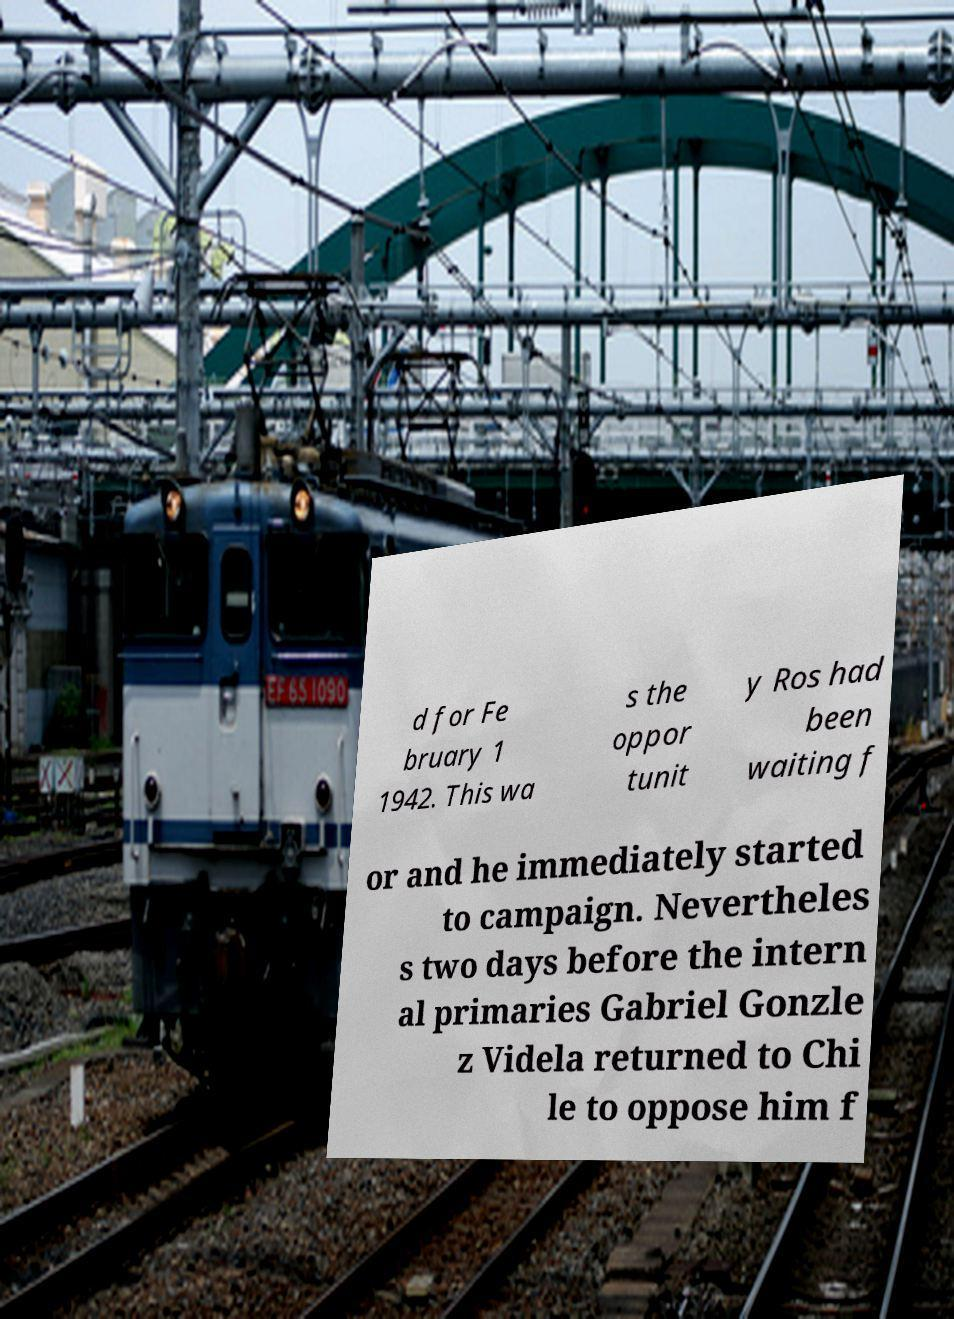Can you read and provide the text displayed in the image?This photo seems to have some interesting text. Can you extract and type it out for me? d for Fe bruary 1 1942. This wa s the oppor tunit y Ros had been waiting f or and he immediately started to campaign. Nevertheles s two days before the intern al primaries Gabriel Gonzle z Videla returned to Chi le to oppose him f 